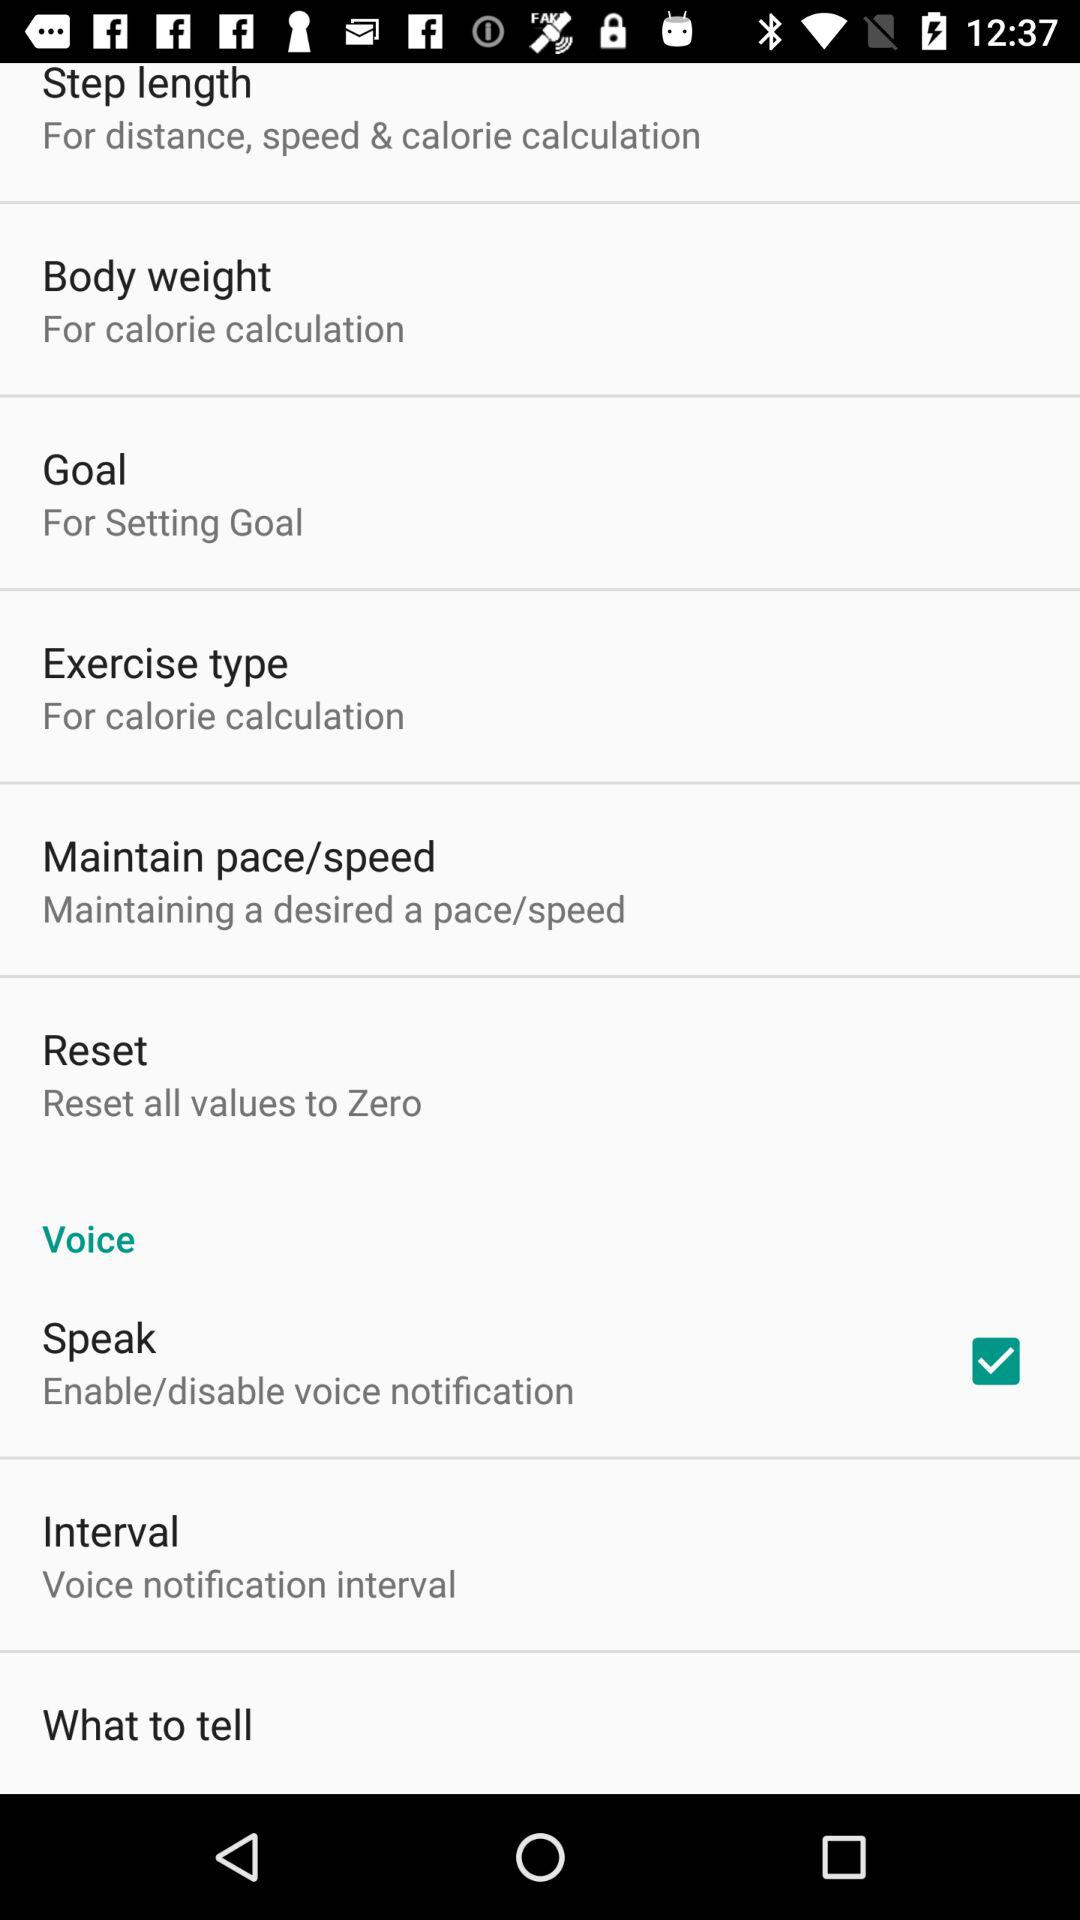What is the status of "Speak"? The status is "on". 